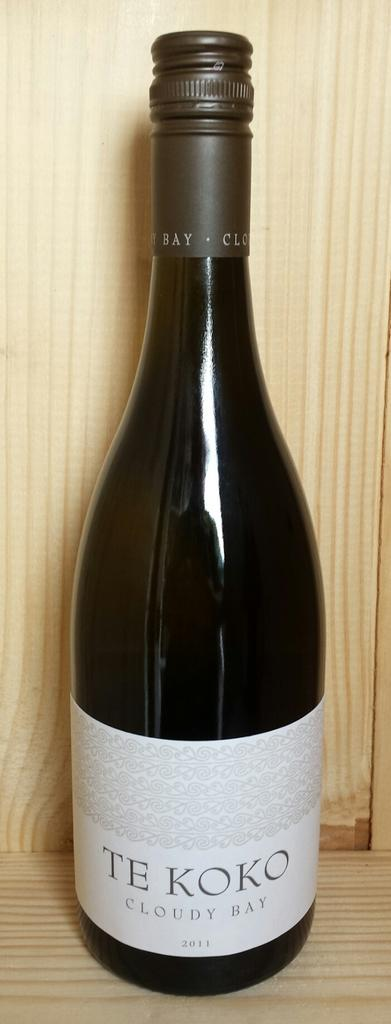<image>
Offer a succinct explanation of the picture presented. a bottle of TE KOKO cloudy bay wine 